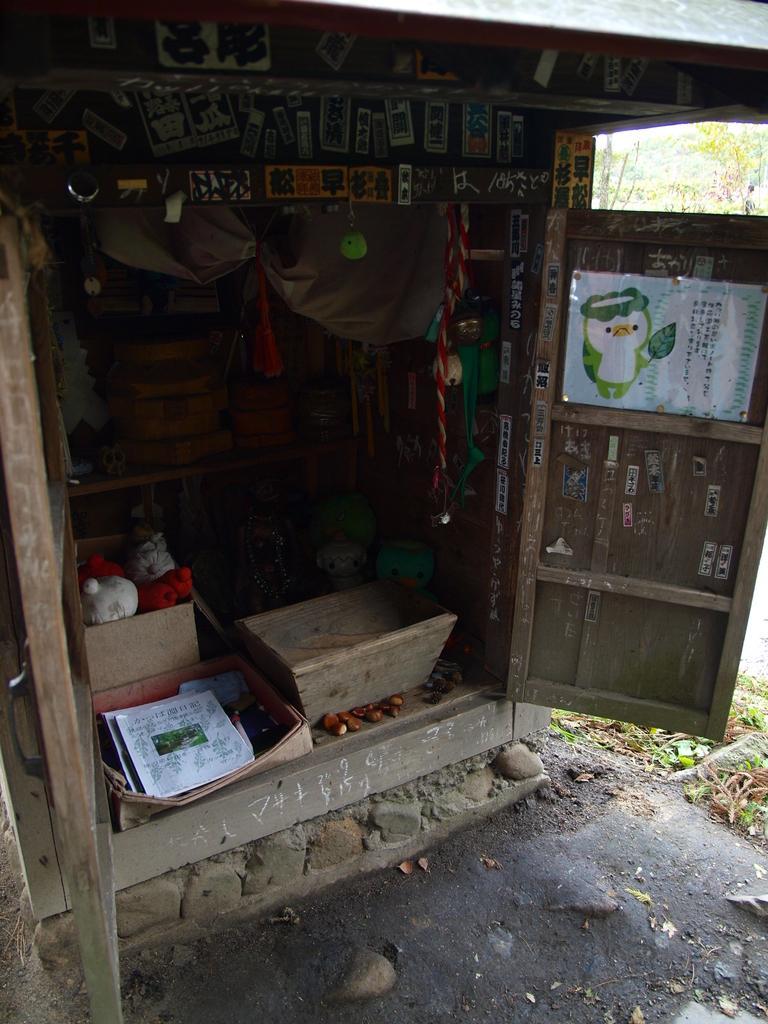In one or two sentences, can you explain what this image depicts? In this picture we can see a shed, posters, toys, door, some objects, leaves on the ground and in the background we can see trees. 